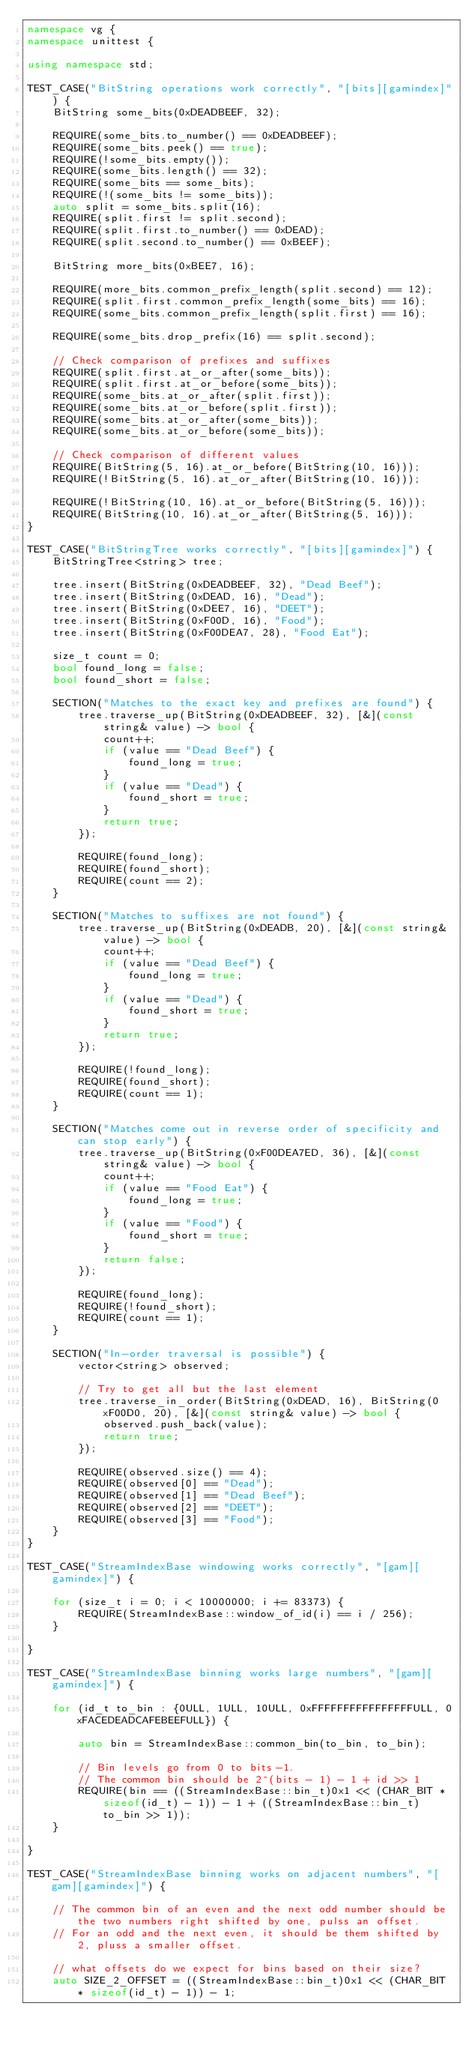<code> <loc_0><loc_0><loc_500><loc_500><_C++_>namespace vg {
namespace unittest {

using namespace std;

TEST_CASE("BitString operations work correctly", "[bits][gamindex]") {
    BitString some_bits(0xDEADBEEF, 32);
    
    REQUIRE(some_bits.to_number() == 0xDEADBEEF);
    REQUIRE(some_bits.peek() == true);
    REQUIRE(!some_bits.empty());
    REQUIRE(some_bits.length() == 32);
    REQUIRE(some_bits == some_bits);
    REQUIRE(!(some_bits != some_bits));
    auto split = some_bits.split(16);
    REQUIRE(split.first != split.second);
    REQUIRE(split.first.to_number() == 0xDEAD);
    REQUIRE(split.second.to_number() == 0xBEEF);
    
    BitString more_bits(0xBEE7, 16);
    
    REQUIRE(more_bits.common_prefix_length(split.second) == 12);
    REQUIRE(split.first.common_prefix_length(some_bits) == 16);
    REQUIRE(some_bits.common_prefix_length(split.first) == 16);
    
    REQUIRE(some_bits.drop_prefix(16) == split.second);
    
    // Check comparison of prefixes and suffixes
    REQUIRE(split.first.at_or_after(some_bits));
    REQUIRE(split.first.at_or_before(some_bits));
    REQUIRE(some_bits.at_or_after(split.first));
    REQUIRE(some_bits.at_or_before(split.first));
    REQUIRE(some_bits.at_or_after(some_bits));
    REQUIRE(some_bits.at_or_before(some_bits));
    
    // Check comparison of different values
    REQUIRE(BitString(5, 16).at_or_before(BitString(10, 16)));
    REQUIRE(!BitString(5, 16).at_or_after(BitString(10, 16)));
    
    REQUIRE(!BitString(10, 16).at_or_before(BitString(5, 16)));
    REQUIRE(BitString(10, 16).at_or_after(BitString(5, 16)));
}

TEST_CASE("BitStringTree works correctly", "[bits][gamindex]") {
    BitStringTree<string> tree;
    
    tree.insert(BitString(0xDEADBEEF, 32), "Dead Beef");
    tree.insert(BitString(0xDEAD, 16), "Dead");
    tree.insert(BitString(0xDEE7, 16), "DEET");
    tree.insert(BitString(0xF00D, 16), "Food");
    tree.insert(BitString(0xF00DEA7, 28), "Food Eat");
    
    size_t count = 0;
    bool found_long = false;
    bool found_short = false;
    
    SECTION("Matches to the exact key and prefixes are found") {
        tree.traverse_up(BitString(0xDEADBEEF, 32), [&](const string& value) -> bool {
            count++;
            if (value == "Dead Beef") {
                found_long = true;
            }
            if (value == "Dead") {
                found_short = true;
            }
            return true;
        });
        
        REQUIRE(found_long);
        REQUIRE(found_short);
        REQUIRE(count == 2);
    }
    
    SECTION("Matches to suffixes are not found") {
        tree.traverse_up(BitString(0xDEADB, 20), [&](const string& value) -> bool {
            count++;
            if (value == "Dead Beef") {
                found_long = true;
            }
            if (value == "Dead") {
                found_short = true;
            }
            return true;
        });
        
        REQUIRE(!found_long);
        REQUIRE(found_short);
        REQUIRE(count == 1);
    }
    
    SECTION("Matches come out in reverse order of specificity and can stop early") {
        tree.traverse_up(BitString(0xF00DEA7ED, 36), [&](const string& value) -> bool {
            count++;
            if (value == "Food Eat") {
                found_long = true;
            }
            if (value == "Food") {
                found_short = true;
            }
            return false;
        });
        
        REQUIRE(found_long);
        REQUIRE(!found_short);
        REQUIRE(count == 1);
    }
    
    SECTION("In-order traversal is possible") {
        vector<string> observed;
        
        // Try to get all but the last element
        tree.traverse_in_order(BitString(0xDEAD, 16), BitString(0xF00D0, 20), [&](const string& value) -> bool {
            observed.push_back(value);
            return true;
        });
        
        REQUIRE(observed.size() == 4);
        REQUIRE(observed[0] == "Dead");
        REQUIRE(observed[1] == "Dead Beef");
        REQUIRE(observed[2] == "DEET");
        REQUIRE(observed[3] == "Food");
    }
}

TEST_CASE("StreamIndexBase windowing works correctly", "[gam][gamindex]") {

    for (size_t i = 0; i < 10000000; i += 83373) {
        REQUIRE(StreamIndexBase::window_of_id(i) == i / 256);
    }

}

TEST_CASE("StreamIndexBase binning works large numbers", "[gam][gamindex]") {

    for (id_t to_bin : {0ULL, 1ULL, 10ULL, 0xFFFFFFFFFFFFFFFFULL, 0xFACEDEADCAFEBEEFULL}) {

        auto bin = StreamIndexBase::common_bin(to_bin, to_bin);

        // Bin levels go from 0 to bits-1.
        // The common bin should be 2^(bits - 1) - 1 + id >> 1
        REQUIRE(bin == ((StreamIndexBase::bin_t)0x1 << (CHAR_BIT * sizeof(id_t) - 1)) - 1 + ((StreamIndexBase::bin_t)to_bin >> 1));
    }
    
}

TEST_CASE("StreamIndexBase binning works on adjacent numbers", "[gam][gamindex]") {
    
    // The common bin of an even and the next odd number should be the two numbers right shifted by one, pulss an offset.
    // For an odd and the next even, it should be them shifted by 2, pluss a smaller offset.
    
    // what offsets do we expect for bins based on their size?
    auto SIZE_2_OFFSET = ((StreamIndexBase::bin_t)0x1 << (CHAR_BIT * sizeof(id_t) - 1)) - 1;</code> 